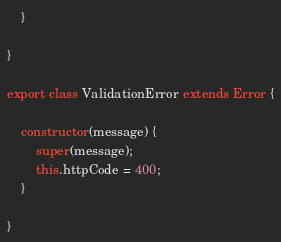<code> <loc_0><loc_0><loc_500><loc_500><_JavaScript_>    }

}

export class ValidationError extends Error {

    constructor(message) {
        super(message);
        this.httpCode = 400;
    }

}
</code> 